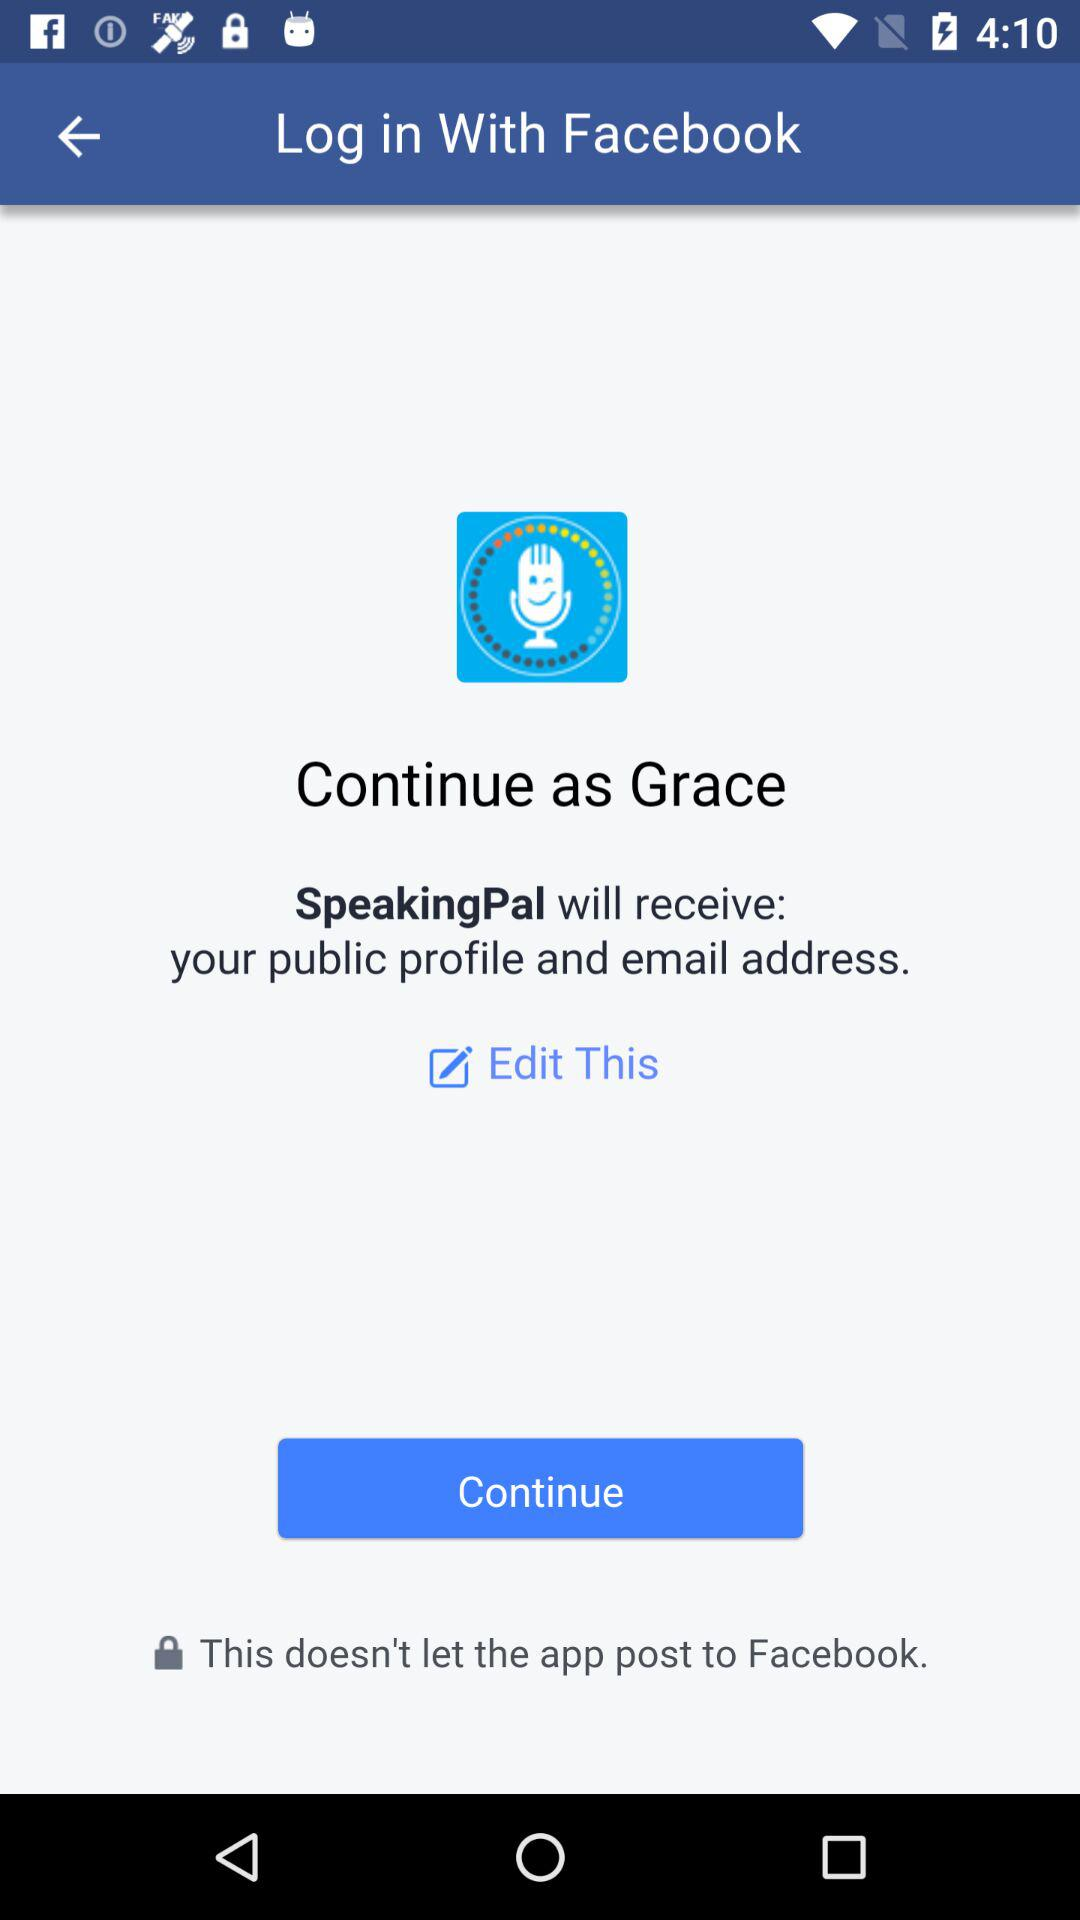What information will SpeakingPal receive? SpeakingPal will receive information about your public profile and email address. 